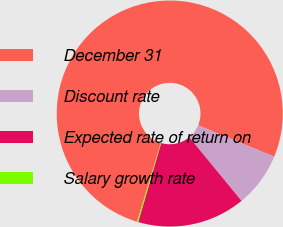<chart> <loc_0><loc_0><loc_500><loc_500><pie_chart><fcel>December 31<fcel>Discount rate<fcel>Expected rate of return on<fcel>Salary growth rate<nl><fcel>76.57%<fcel>7.81%<fcel>15.45%<fcel>0.17%<nl></chart> 